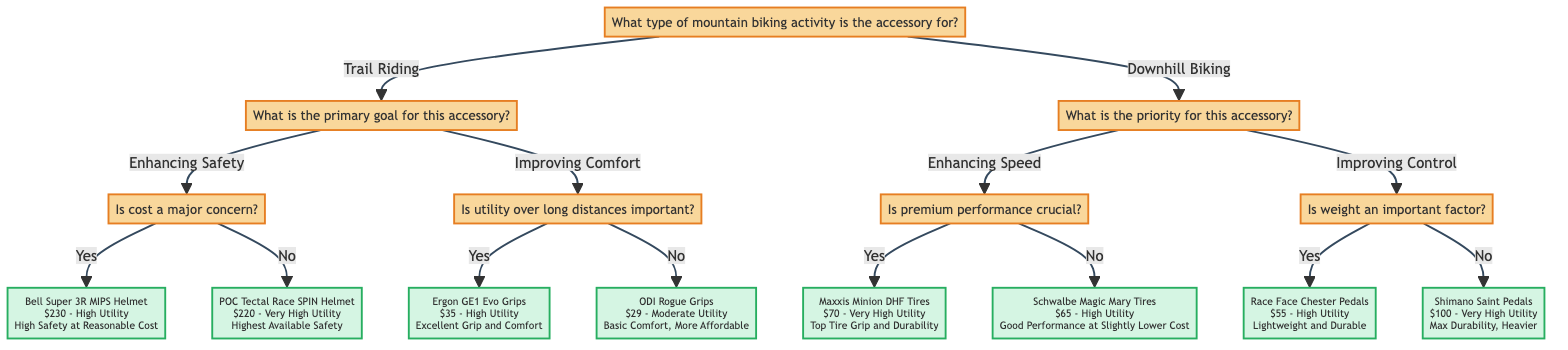What question is at the root of the diagram? The root question of the diagram is "What type of mountain biking activity is the accessory for?" This is the first decision point, leading to two main categories: Trail Riding and Downhill Biking.
Answer: What type of mountain biking activity is the accessory for? How many options are there under "Trail Riding"? Under "Trail Riding," there are two options provided: "Enhancing Safety" and "Improving Comfort." Each option leads to further decision questions.
Answer: 2 What accessory is recommended for enhancing safety with cost as a major concern? If the primary goal is enhancing safety and cost is a major concern, the accessory recommended is the "Bell Super 3R MIPS Helmet," which is listed with the details of cost and utility.
Answer: Bell Super 3R MIPS Helmet What is the utility level of the Ergon GE1 Evo Grips? The utility level of the Ergon GE1 Evo Grips, which are recommended for improving comfort over long distances, is categorized as "High."
Answer: High Which accessory is suggested if premium performance is not crucial in enhancing speed? If premium performance is not crucial for enhancing speed, the suggested accessory is the "Schwalbe Magic Mary Tires," which balances performance and cost effectively.
Answer: Schwalbe Magic Mary Tires What is the cost of Shimano Saint Pedals? The cost indicated for the Shimano Saint Pedals, which are recommended for their durability, is $100. This is clearly mentioned as it follows the option path for improving control.
Answer: $100 What relationship exists between "Improving Comfort" and "Ergon GE1 Evo Grips"? "Improving Comfort" is one of the main options stemming from "Trail Riding," and it leads directly to the Ergon GE1 Evo Grips as the recommended accessory if utility over long distances is deemed important.
Answer: Direct relationship How many total unique accessories are identified in the diagram? The diagram lists a total of six unique accessories, each associated with specific decision paths and performance preferences, under both main types of mountain biking activities.
Answer: 6 What accessory is ideal for lightweight and durable pedal options? The Race Face Chester Pedals are ideal for those prioritizing lightweight and durable pedal options, as specified in the decision path concerning control improvement.
Answer: Race Face Chester Pedals 